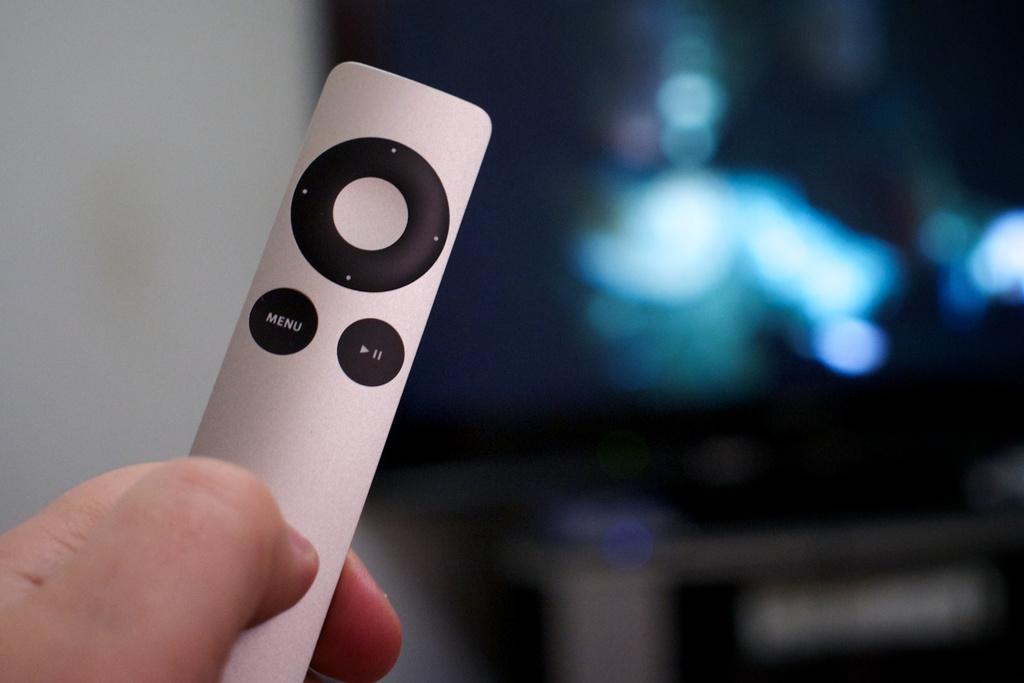What word is listed on the remote?
Offer a terse response. Menu. 